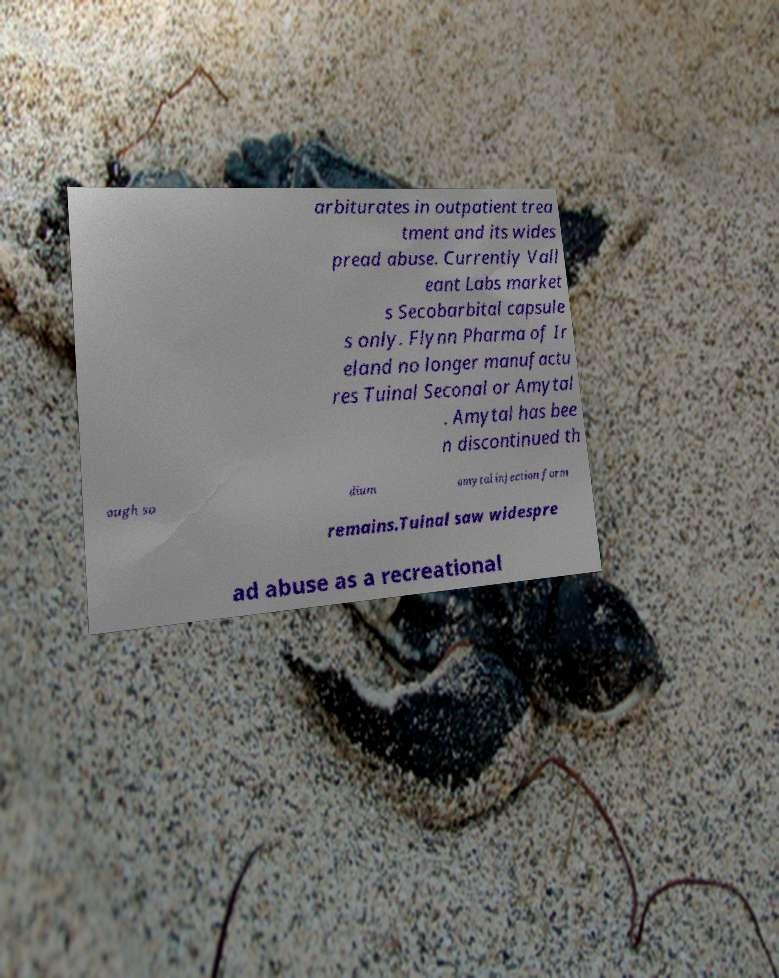There's text embedded in this image that I need extracted. Can you transcribe it verbatim? arbiturates in outpatient trea tment and its wides pread abuse. Currently Vall eant Labs market s Secobarbital capsule s only. Flynn Pharma of Ir eland no longer manufactu res Tuinal Seconal or Amytal . Amytal has bee n discontinued th ough so dium amytal injection form remains.Tuinal saw widespre ad abuse as a recreational 